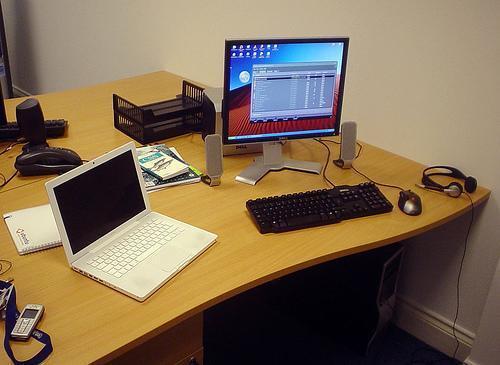How many laptops are in the picture?
Give a very brief answer. 1. How many pairs of earphones are on the table?
Give a very brief answer. 1. 